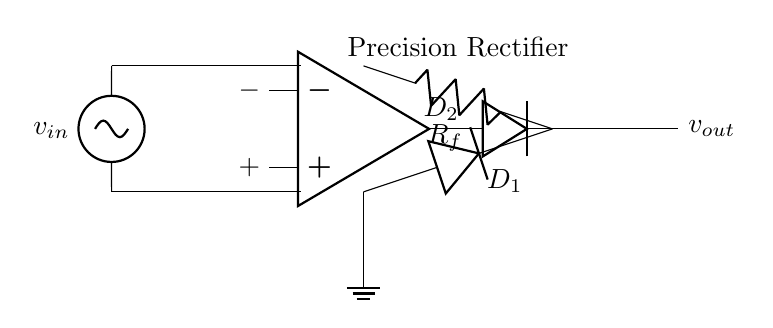What is the primary function of the precision rectifier circuit? The primary function is to accurately rectify AC voltage signals into DC without the typical threshold issues found in standard rectifiers, which is necessary for precise voltage measurements.
Answer: Accurate rectification What are the two types of diodes used in this circuit? The two types of diodes present are D1 and D2, which serve to ensure that both halves of the AC waveform are used for rectification.
Answer: D1 and D2 What is the role of the operational amplifier in this circuit? The operational amplifier (op-amp) amplifies the input AC signal, allowing for a more precise control over the rectification process, thus improving accuracy in measurement.
Answer: Amplification Which component is responsible for providing feedback in the circuit? The feedback in this precision rectifier circuit is provided by the resistor Rf, which helps stabilize the gain and improve the performance of the op-amp within the circuit.
Answer: Rf What does the output voltage represent in this circuit? The output voltage, denoted as v_out, represents the rectified DC voltage that can be measured by the multimeter, demonstrating the circuit's ability to convert AC input into a usable DC output.
Answer: v_out 